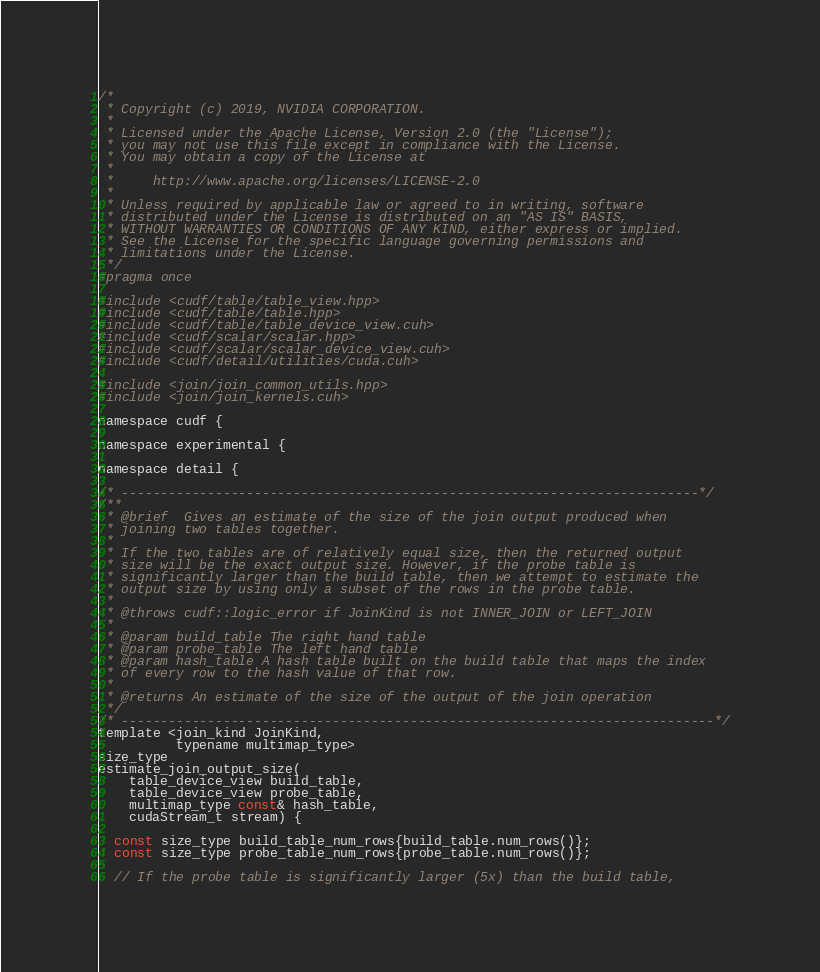<code> <loc_0><loc_0><loc_500><loc_500><_Cuda_>/*
 * Copyright (c) 2019, NVIDIA CORPORATION.
 *
 * Licensed under the Apache License, Version 2.0 (the "License");
 * you may not use this file except in compliance with the License.
 * You may obtain a copy of the License at
 *
 *     http://www.apache.org/licenses/LICENSE-2.0
 *
 * Unless required by applicable law or agreed to in writing, software
 * distributed under the License is distributed on an "AS IS" BASIS,
 * WITHOUT WARRANTIES OR CONDITIONS OF ANY KIND, either express or implied.
 * See the License for the specific language governing permissions and
 * limitations under the License.
 */
#pragma once

#include <cudf/table/table_view.hpp>
#include <cudf/table/table.hpp>
#include <cudf/table/table_device_view.cuh>
#include <cudf/scalar/scalar.hpp>
#include <cudf/scalar/scalar_device_view.cuh>
#include <cudf/detail/utilities/cuda.cuh>

#include <join/join_common_utils.hpp>
#include <join/join_kernels.cuh>

namespace cudf {

namespace experimental {

namespace detail {

/* --------------------------------------------------------------------------*/
/**
 * @brief  Gives an estimate of the size of the join output produced when
 * joining two tables together.
 *
 * If the two tables are of relatively equal size, then the returned output
 * size will be the exact output size. However, if the probe table is
 * significantly larger than the build table, then we attempt to estimate the
 * output size by using only a subset of the rows in the probe table.
 *
 * @throws cudf::logic_error if JoinKind is not INNER_JOIN or LEFT_JOIN
 *
 * @param build_table The right hand table
 * @param probe_table The left hand table
 * @param hash_table A hash table built on the build table that maps the index
 * of every row to the hash value of that row.
 *
 * @returns An estimate of the size of the output of the join operation
 */
/* ----------------------------------------------------------------------------*/
template <join_kind JoinKind,
          typename multimap_type>
size_type
estimate_join_output_size(
    table_device_view build_table,
    table_device_view probe_table,
    multimap_type const& hash_table,
    cudaStream_t stream) {

  const size_type build_table_num_rows{build_table.num_rows()};
  const size_type probe_table_num_rows{probe_table.num_rows()};

  // If the probe table is significantly larger (5x) than the build table,</code> 